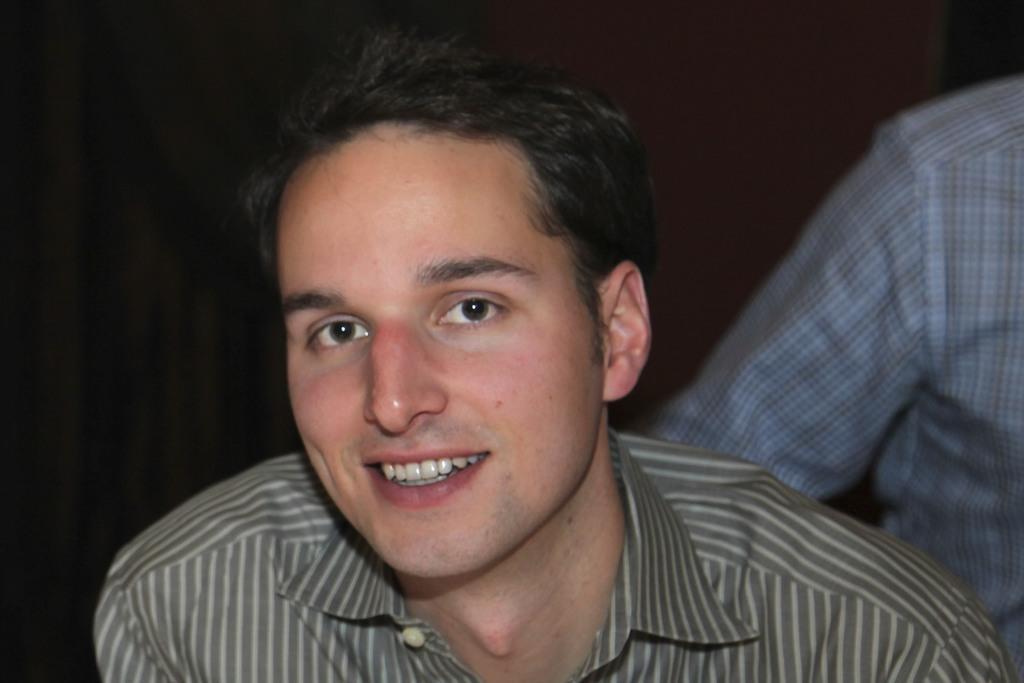Can you describe this image briefly? In the image i can see a person who is smiling,behind him there is another person and i can see the background is black. 